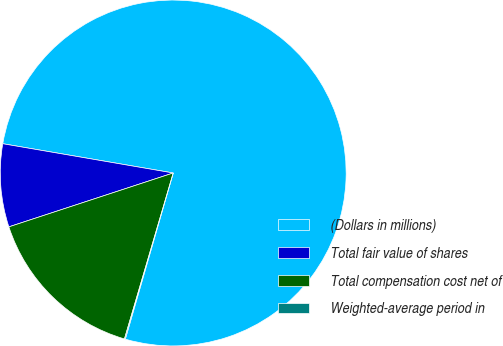Convert chart. <chart><loc_0><loc_0><loc_500><loc_500><pie_chart><fcel>(Dollars in millions)<fcel>Total fair value of shares<fcel>Total compensation cost net of<fcel>Weighted-average period in<nl><fcel>76.76%<fcel>7.75%<fcel>15.41%<fcel>0.08%<nl></chart> 